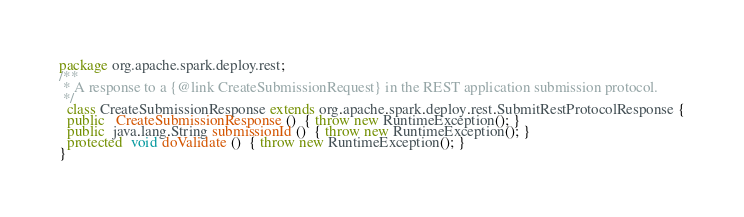<code> <loc_0><loc_0><loc_500><loc_500><_Java_>package org.apache.spark.deploy.rest;
/**
 * A response to a {@link CreateSubmissionRequest} in the REST application submission protocol.
 */
  class CreateSubmissionResponse extends org.apache.spark.deploy.rest.SubmitRestProtocolResponse {
  public   CreateSubmissionResponse ()  { throw new RuntimeException(); }
  public  java.lang.String submissionId ()  { throw new RuntimeException(); }
  protected  void doValidate ()  { throw new RuntimeException(); }
}
</code> 